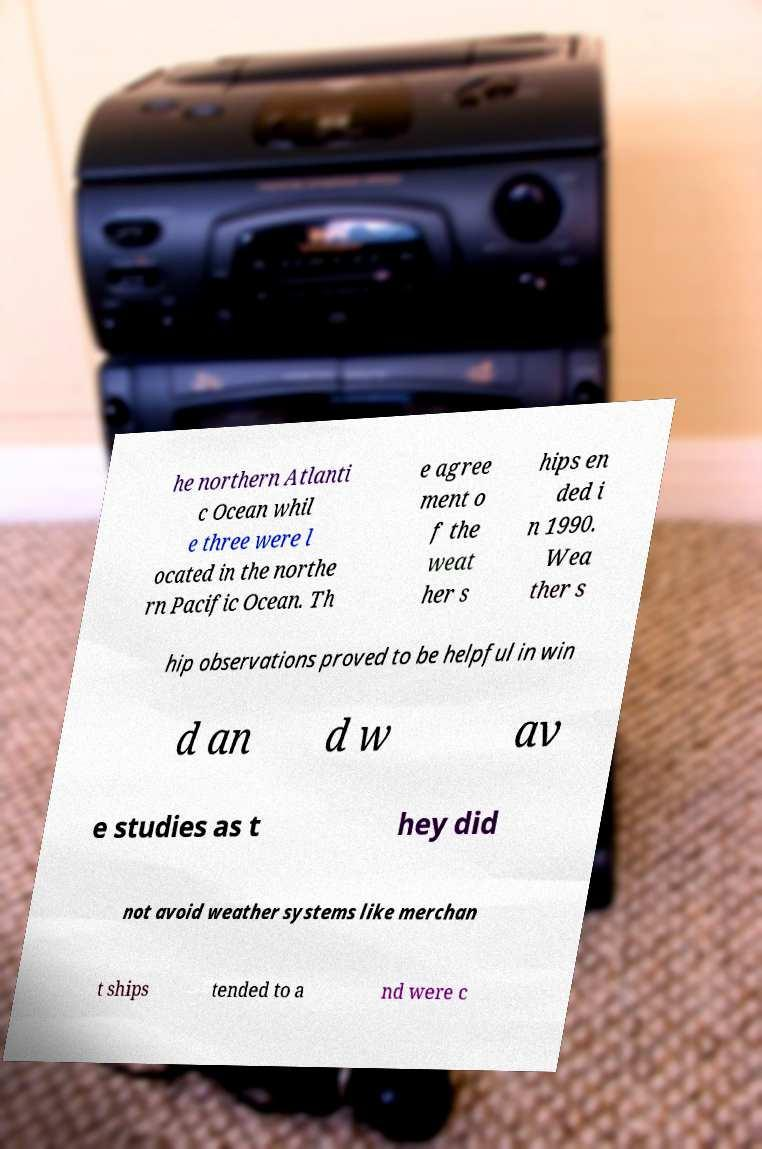I need the written content from this picture converted into text. Can you do that? he northern Atlanti c Ocean whil e three were l ocated in the northe rn Pacific Ocean. Th e agree ment o f the weat her s hips en ded i n 1990. Wea ther s hip observations proved to be helpful in win d an d w av e studies as t hey did not avoid weather systems like merchan t ships tended to a nd were c 